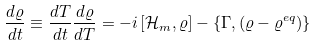Convert formula to latex. <formula><loc_0><loc_0><loc_500><loc_500>\frac { d \varrho } { d t } \equiv \frac { d T } { d t } \frac { d \varrho } { d T } = - i \left [ { \mathcal { H } } _ { m } , \varrho \right ] - \left \{ \Gamma , ( \varrho - \varrho ^ { e q } ) \right \}</formula> 